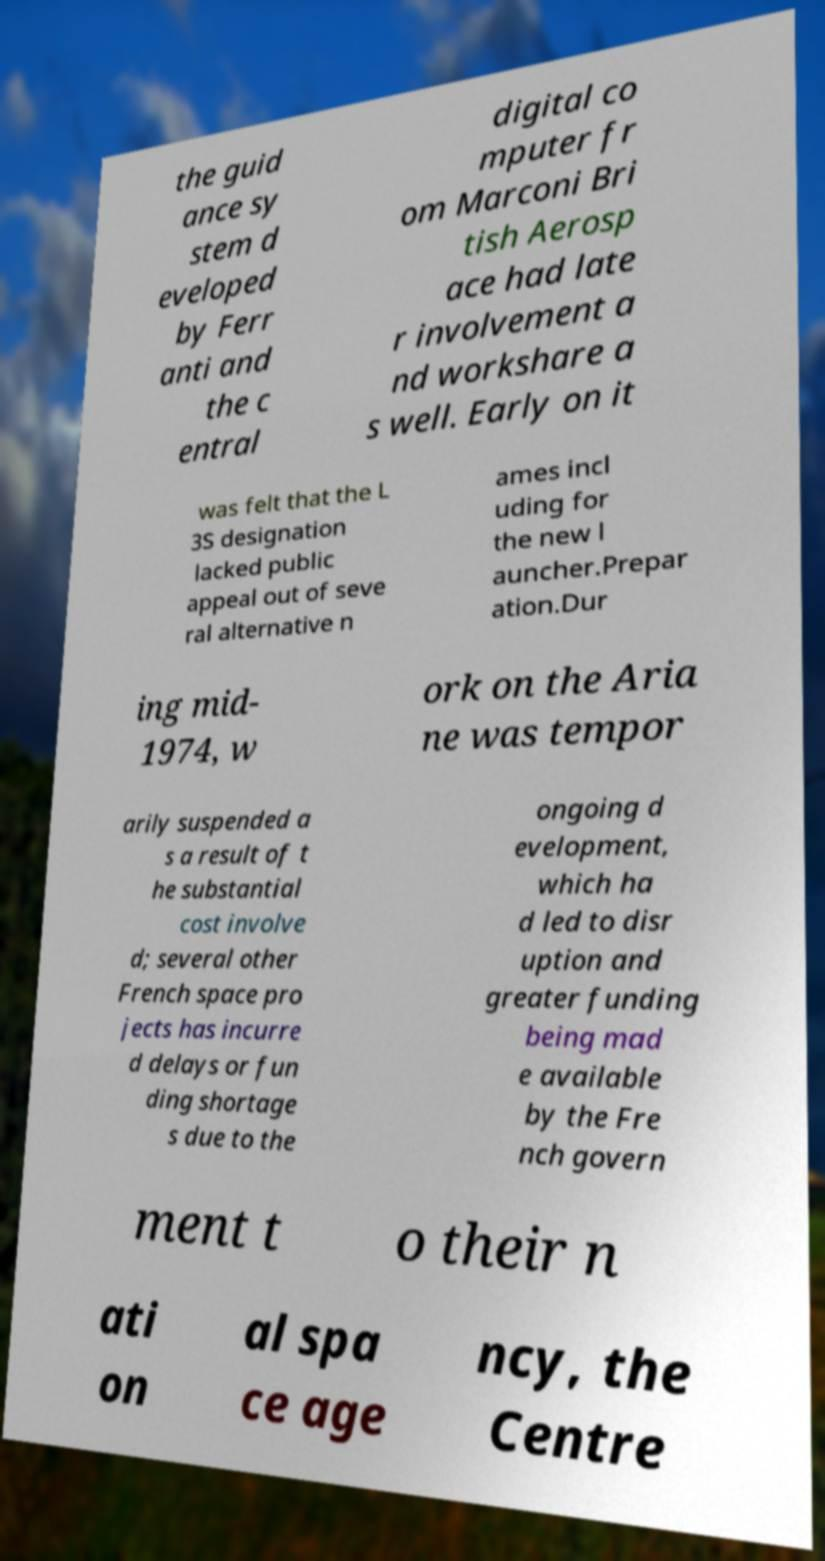I need the written content from this picture converted into text. Can you do that? the guid ance sy stem d eveloped by Ferr anti and the c entral digital co mputer fr om Marconi Bri tish Aerosp ace had late r involvement a nd workshare a s well. Early on it was felt that the L 3S designation lacked public appeal out of seve ral alternative n ames incl uding for the new l auncher.Prepar ation.Dur ing mid- 1974, w ork on the Aria ne was tempor arily suspended a s a result of t he substantial cost involve d; several other French space pro jects has incurre d delays or fun ding shortage s due to the ongoing d evelopment, which ha d led to disr uption and greater funding being mad e available by the Fre nch govern ment t o their n ati on al spa ce age ncy, the Centre 